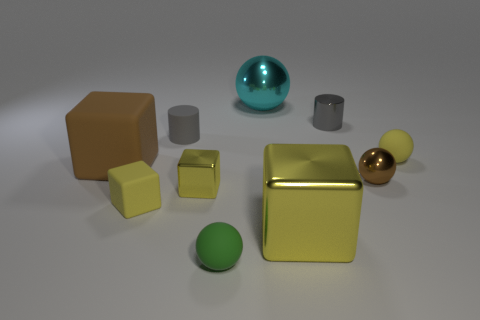What number of other small cylinders have the same color as the matte cylinder?
Your answer should be very brief. 1. Are there fewer matte spheres that are behind the tiny green object than tiny yellow things that are in front of the small brown ball?
Offer a very short reply. Yes. What is the size of the gray cylinder on the left side of the big cyan shiny sphere?
Give a very brief answer. Small. There is a object that is the same color as the shiny cylinder; what is its size?
Provide a short and direct response. Small. Are there any small things made of the same material as the tiny yellow ball?
Your response must be concise. Yes. Is the material of the small yellow ball the same as the brown cube?
Your answer should be compact. Yes. The metallic block that is the same size as the green thing is what color?
Your answer should be very brief. Yellow. How many other things are the same shape as the big cyan thing?
Provide a succinct answer. 3. There is a brown metallic sphere; is it the same size as the sphere behind the gray rubber cylinder?
Ensure brevity in your answer.  No. How many things are tiny yellow metal blocks or small green things?
Your answer should be compact. 2. 